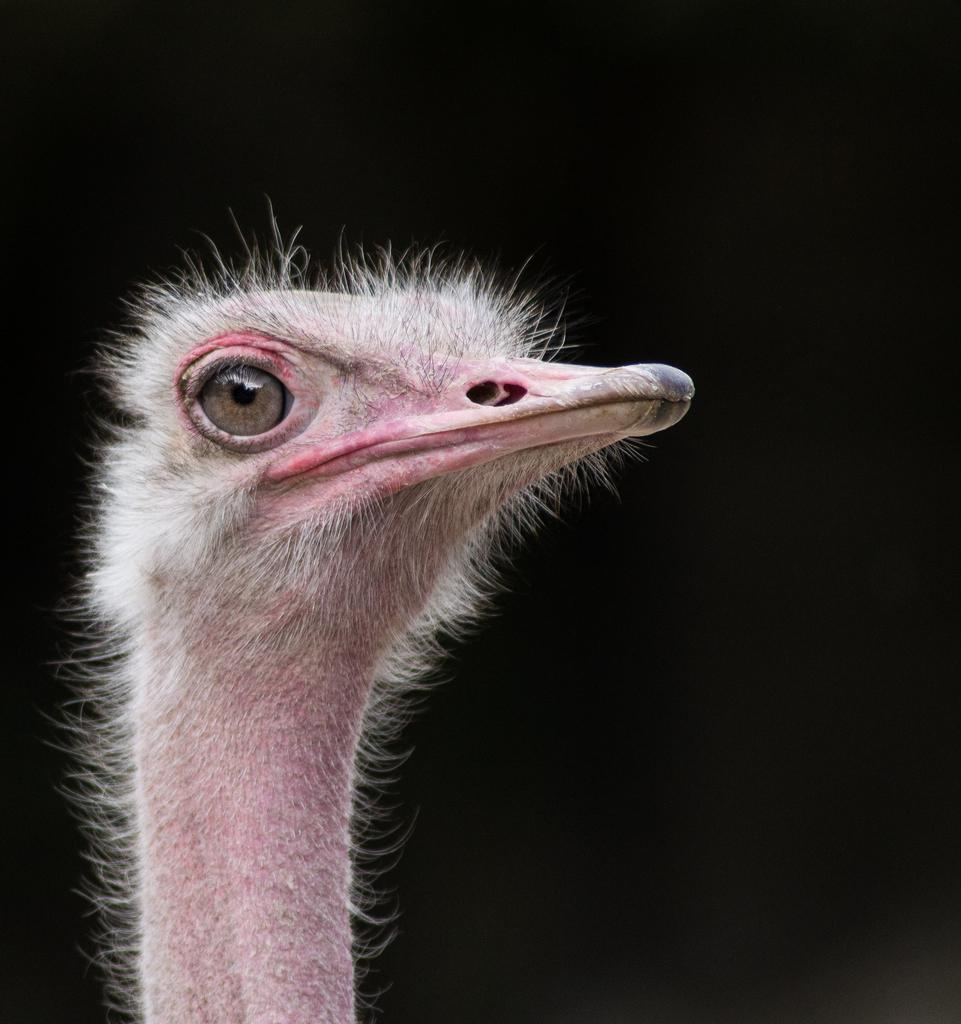What is the main subject in the center of the image? There is an ostrich in the center of the image. How many thumbs can be seen on the ostrich in the image? Ostriches do not have thumbs, so none can be seen on the ostrich in the image. What type of bubble is floating near the ostrich in the image? There are no bubbles present in the image; it features an ostrich as the main subject. 